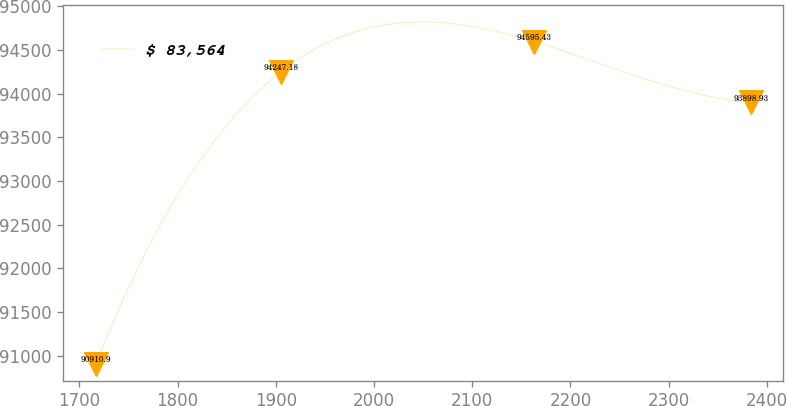Convert chart to OTSL. <chart><loc_0><loc_0><loc_500><loc_500><line_chart><ecel><fcel>$ 83,564<nl><fcel>1716.82<fcel>90910.9<nl><fcel>1904.94<fcel>94247.2<nl><fcel>2163.15<fcel>94595.4<nl><fcel>2383.45<fcel>93898.9<nl></chart> 